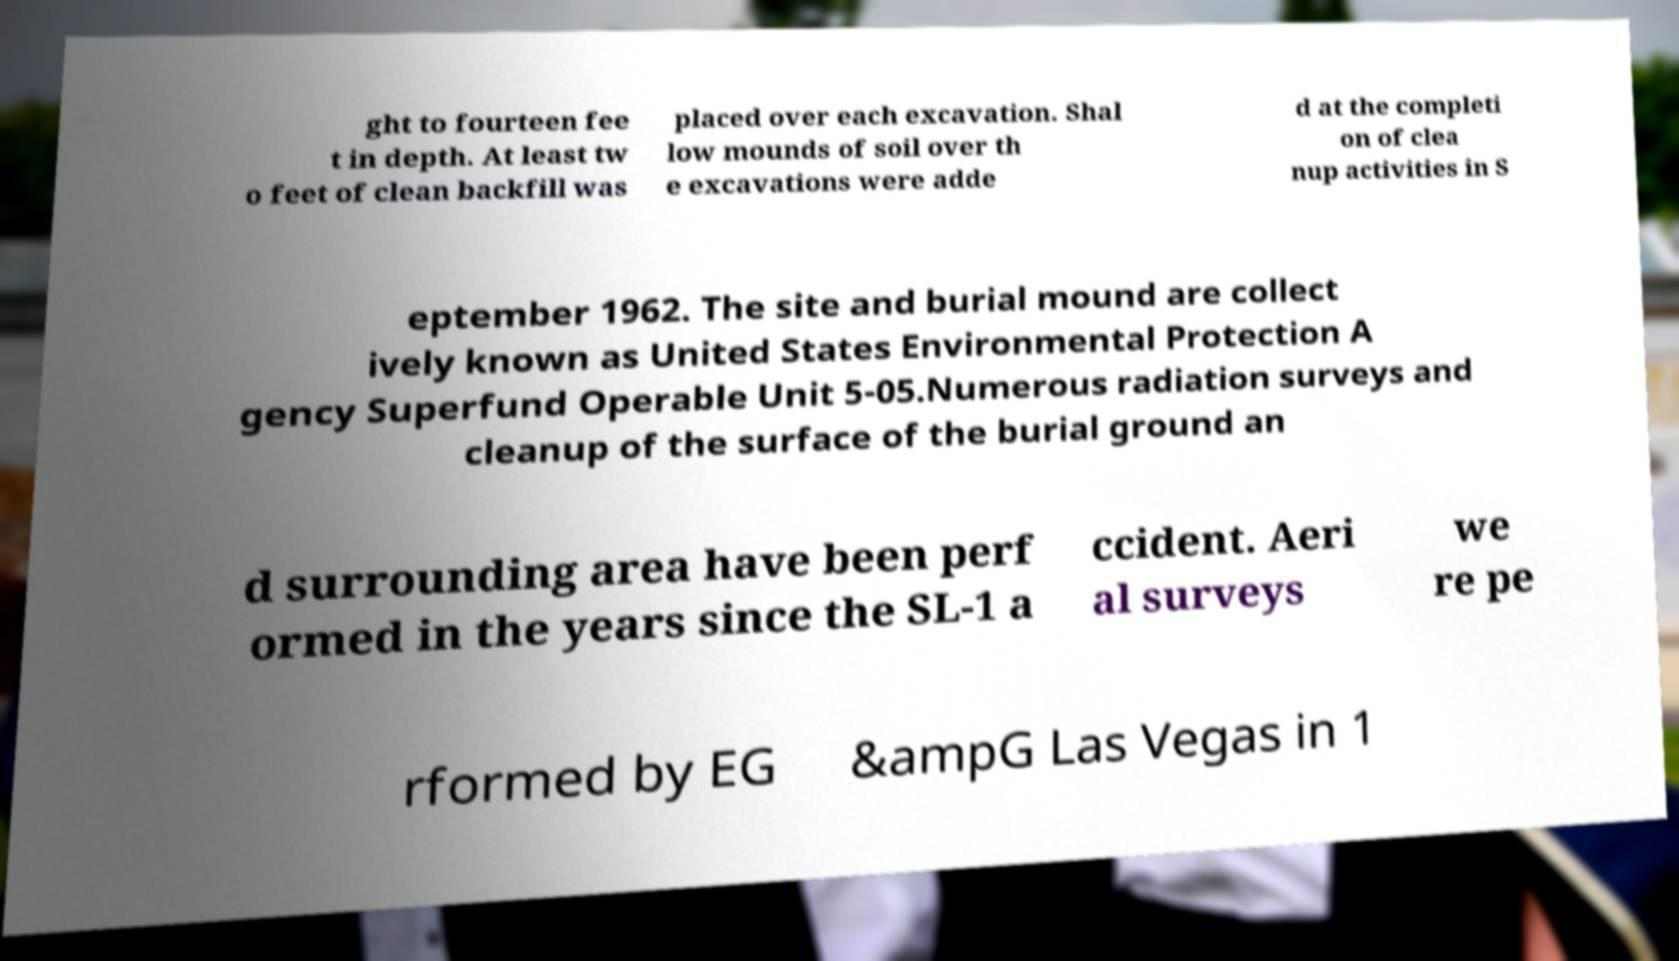For documentation purposes, I need the text within this image transcribed. Could you provide that? ght to fourteen fee t in depth. At least tw o feet of clean backfill was placed over each excavation. Shal low mounds of soil over th e excavations were adde d at the completi on of clea nup activities in S eptember 1962. The site and burial mound are collect ively known as United States Environmental Protection A gency Superfund Operable Unit 5-05.Numerous radiation surveys and cleanup of the surface of the burial ground an d surrounding area have been perf ormed in the years since the SL-1 a ccident. Aeri al surveys we re pe rformed by EG &ampG Las Vegas in 1 